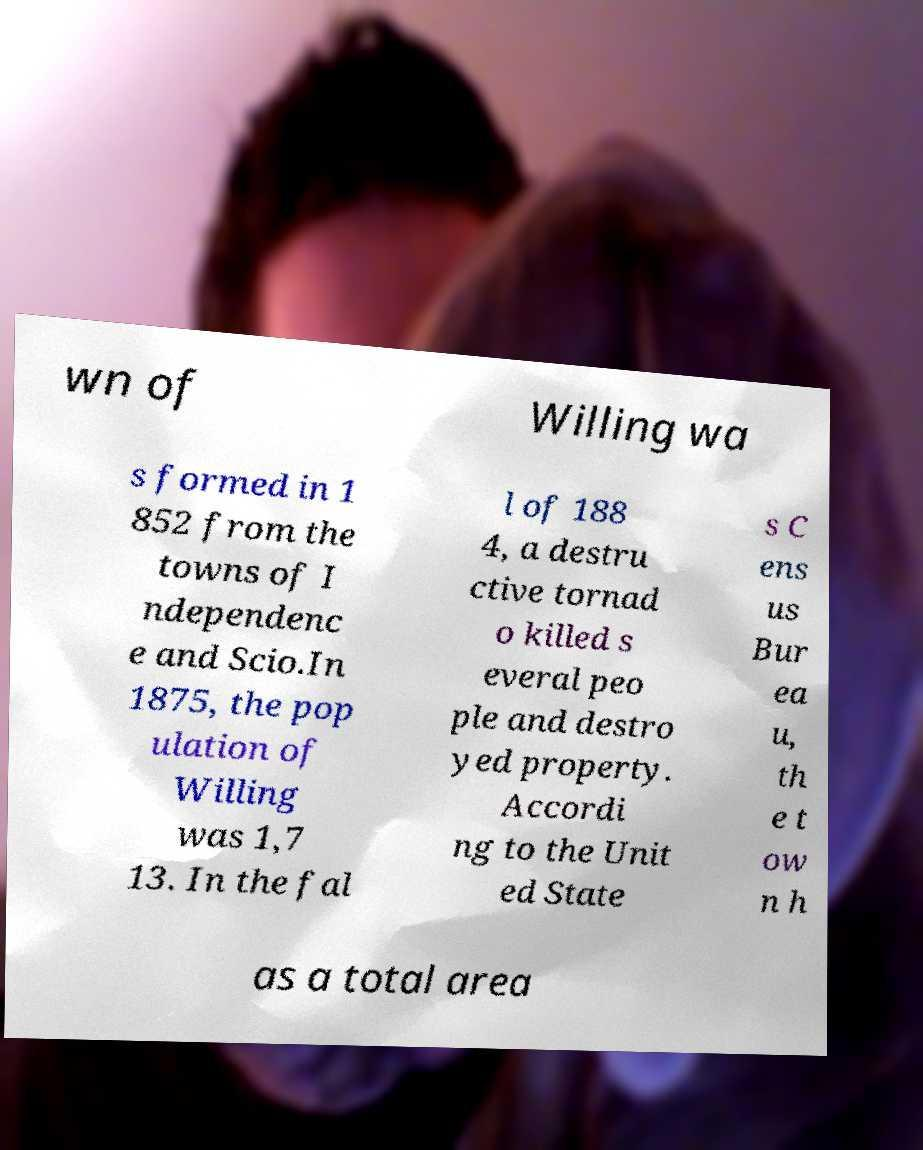There's text embedded in this image that I need extracted. Can you transcribe it verbatim? wn of Willing wa s formed in 1 852 from the towns of I ndependenc e and Scio.In 1875, the pop ulation of Willing was 1,7 13. In the fal l of 188 4, a destru ctive tornad o killed s everal peo ple and destro yed property. Accordi ng to the Unit ed State s C ens us Bur ea u, th e t ow n h as a total area 